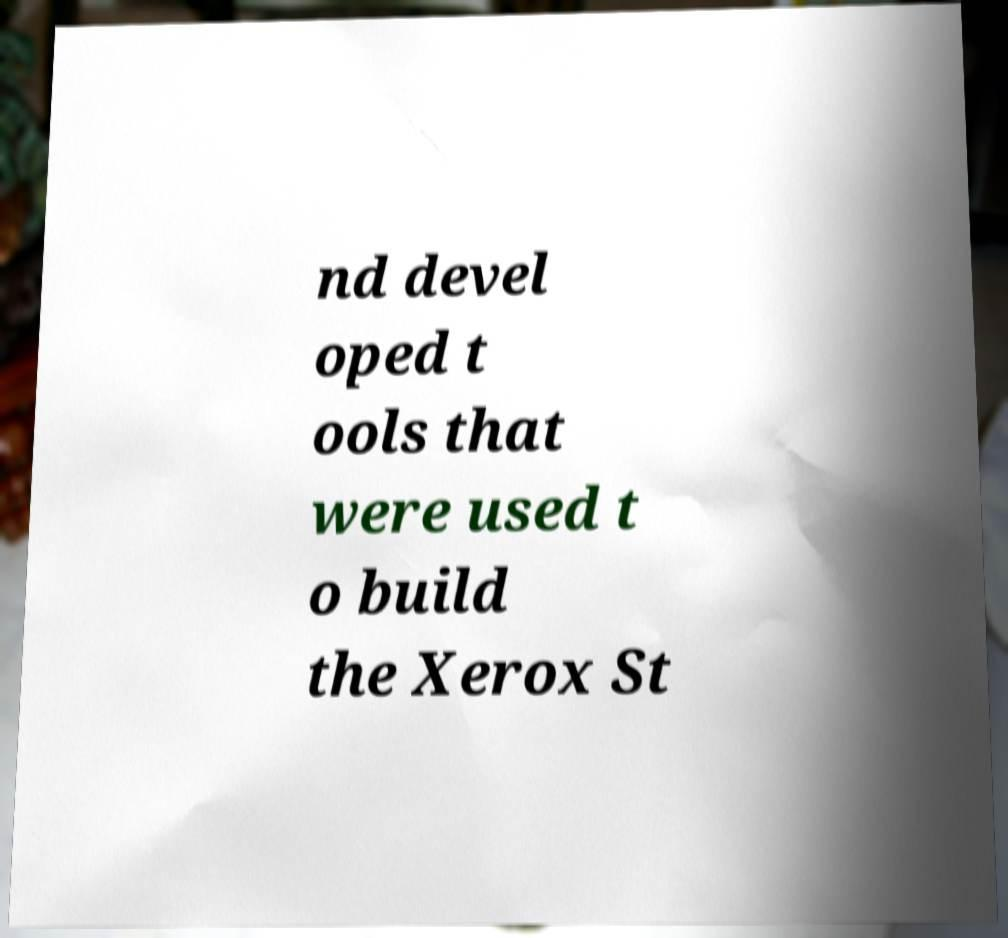Can you accurately transcribe the text from the provided image for me? nd devel oped t ools that were used t o build the Xerox St 